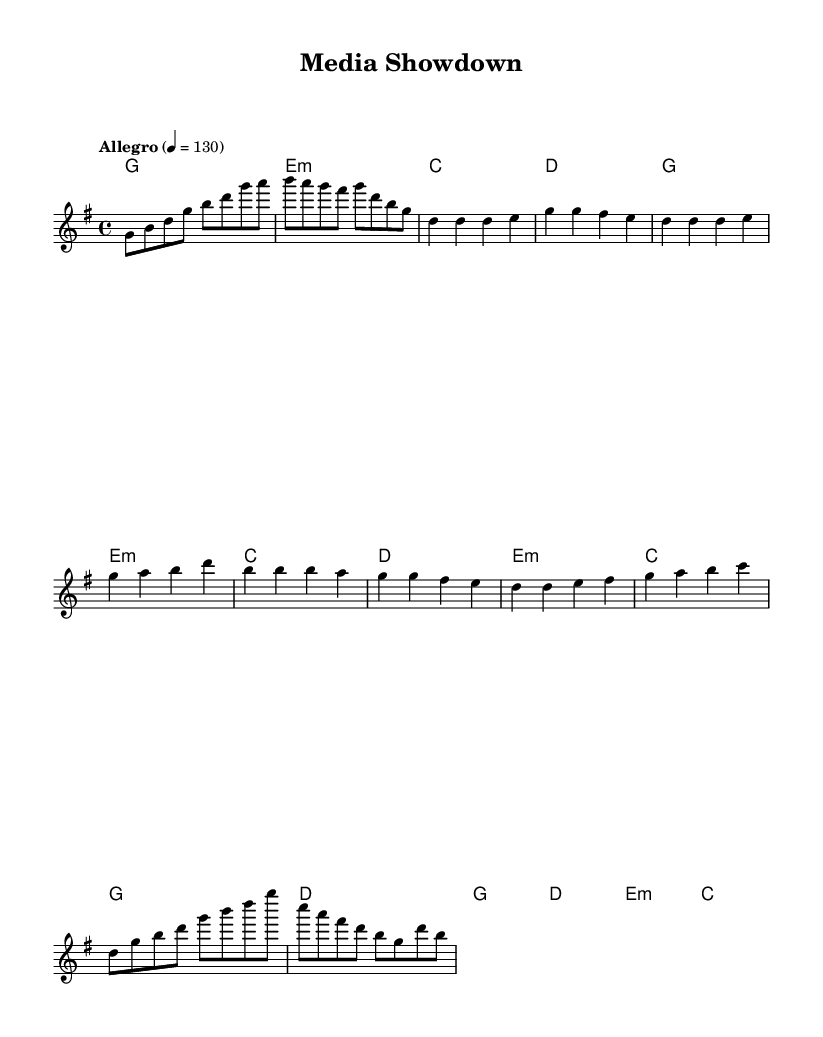What is the key signature of this music? The key signature is G major, which has one sharp (F#). This is determined by reading the key indication at the beginning of the score.
Answer: G major What is the time signature of this music? The time signature is 4/4, indicated at the beginning of the sheet music. It means there are four beats per measure.
Answer: 4/4 What is the tempo marking of this music? The tempo marking is "Allegro," which indicates a fast speed of performance. The specific speed is set at quarter note = 130 beats per minute.
Answer: Allegro How many measures are in the chorus section? The chorus section consists of 4 measures, as indicated by the notation in the sheet music.
Answer: 4 measures What is the first note of the song? The first note of the song is G, which is located in the melody line at the very beginning of the score.
Answer: G Which chord is played in the first measure? The chord played in the first measure is G major, as shown in the chord names line beneath the melody.
Answer: G major What theme does this song's lyrics likely explore based on its title? The title of the song, "Media Showdown," suggests themes of rivalry and competition, likely presenting a narrative about conflicts within the media industry.
Answer: Rivalry and competition 